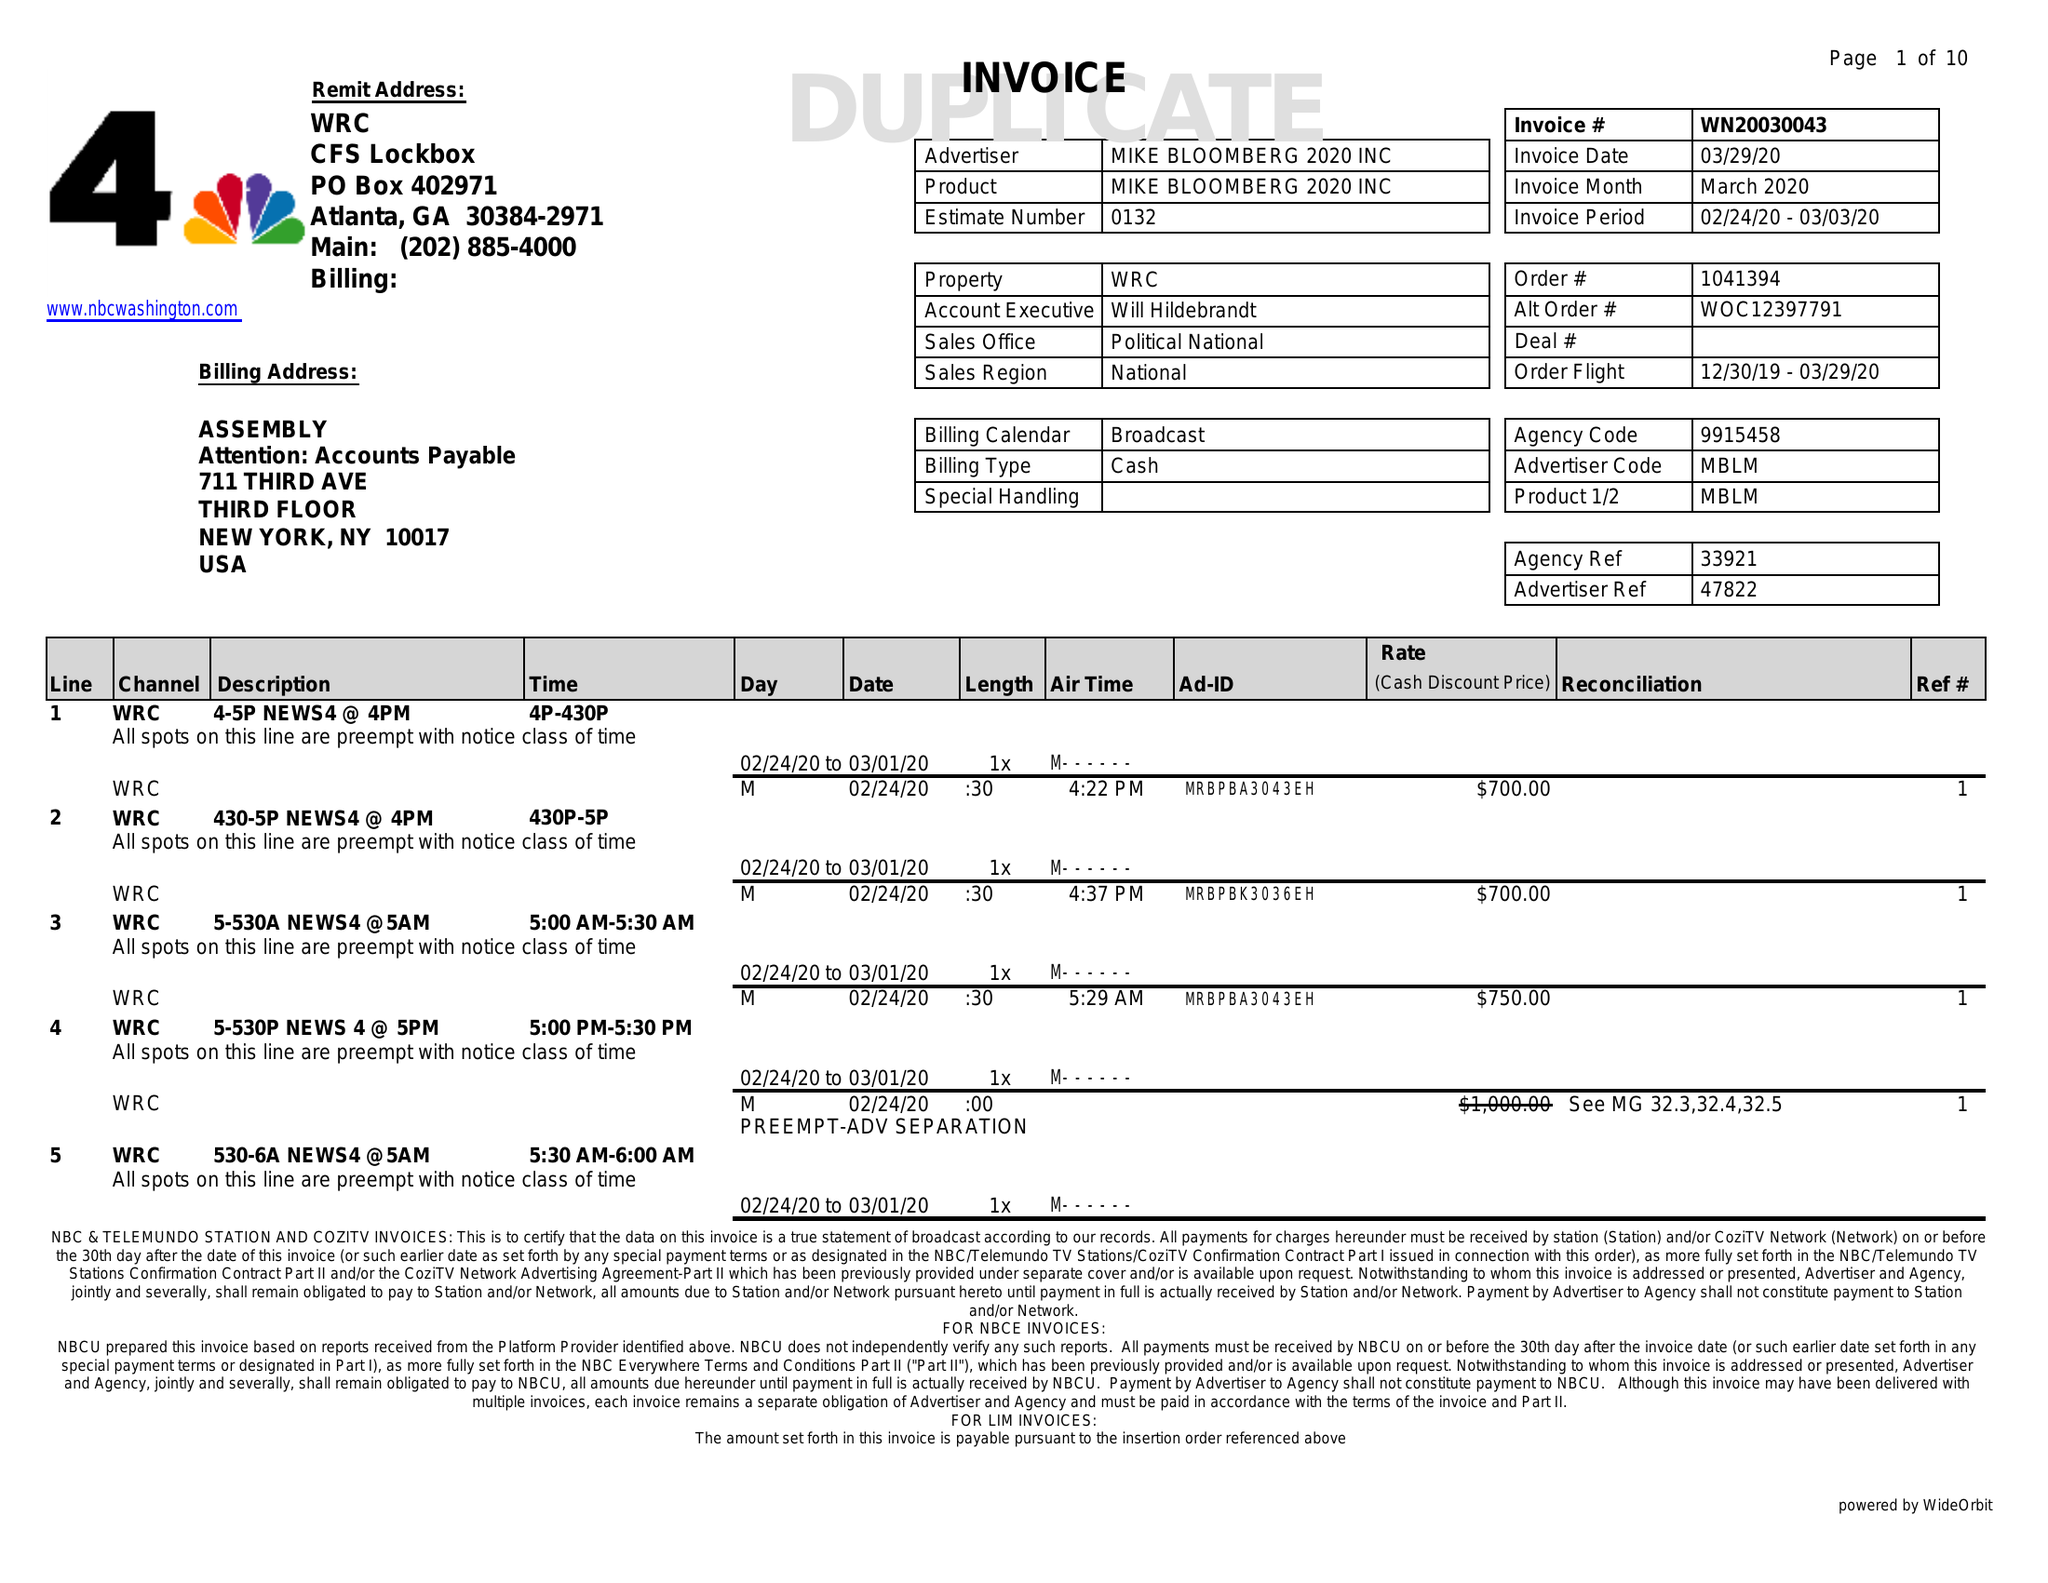What is the value for the flight_from?
Answer the question using a single word or phrase. 12/30/19 